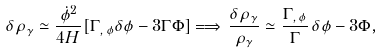Convert formula to latex. <formula><loc_0><loc_0><loc_500><loc_500>\delta \rho _ { \gamma } \simeq \frac { \dot { \phi } ^ { 2 } } { 4 H } [ \Gamma _ { , \, \phi } \delta \phi - 3 \Gamma \Phi ] \Longrightarrow \, \frac { \delta \rho _ { \gamma } } { \rho _ { \gamma } } \simeq \frac { \Gamma _ { , \, \phi } } { \Gamma } \, \delta \phi - 3 \Phi ,</formula> 